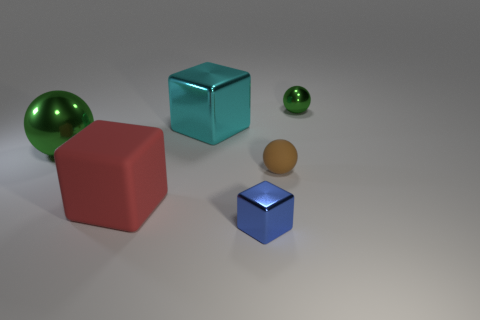What is the big red object made of?
Your answer should be very brief. Rubber. There is a blue shiny object; are there any big matte objects on the right side of it?
Make the answer very short. No. Is the large red object the same shape as the large cyan thing?
Your answer should be very brief. Yes. What number of other objects are there of the same size as the cyan metallic thing?
Your answer should be compact. 2. What number of objects are big blocks in front of the cyan block or red metallic balls?
Offer a very short reply. 1. The rubber block has what color?
Provide a short and direct response. Red. There is a brown thing that is in front of the cyan metallic block; what is its material?
Offer a very short reply. Rubber. There is a red thing; is its shape the same as the thing that is in front of the matte block?
Provide a succinct answer. Yes. Is the number of large red rubber things greater than the number of yellow matte cylinders?
Keep it short and to the point. Yes. Are there any other things that are the same color as the small cube?
Offer a terse response. No. 